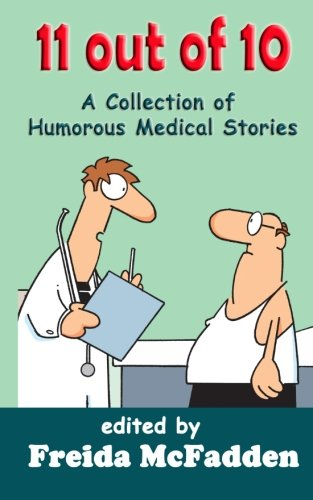Who is the author of this book? The book, as shown on the cover, is edited by Freida McFadden. She's recognized for her engaging writing style, especially in medical-related narratives. 